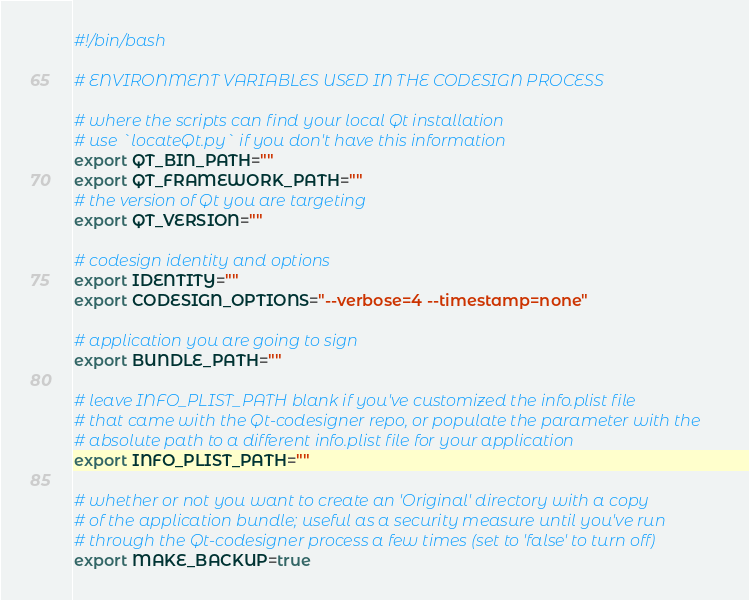<code> <loc_0><loc_0><loc_500><loc_500><_Bash_>#!/bin/bash

# ENVIRONMENT VARIABLES USED IN THE CODESIGN PROCESS

# where the scripts can find your local Qt installation
# use `locateQt.py` if you don't have this information
export QT_BIN_PATH=""
export QT_FRAMEWORK_PATH=""
# the version of Qt you are targeting
export QT_VERSION=""

# codesign identity and options
export IDENTITY=""
export CODESIGN_OPTIONS="--verbose=4 --timestamp=none"

# application you are going to sign
export BUNDLE_PATH=""

# leave INFO_PLIST_PATH blank if you've customized the info.plist file 
# that came with the Qt-codesigner repo, or populate the parameter with the
# absolute path to a different info.plist file for your application
export INFO_PLIST_PATH=""

# whether or not you want to create an 'Original' directory with a copy
# of the application bundle; useful as a security measure until you've run 
# through the Qt-codesigner process a few times (set to 'false' to turn off)
export MAKE_BACKUP=true</code> 